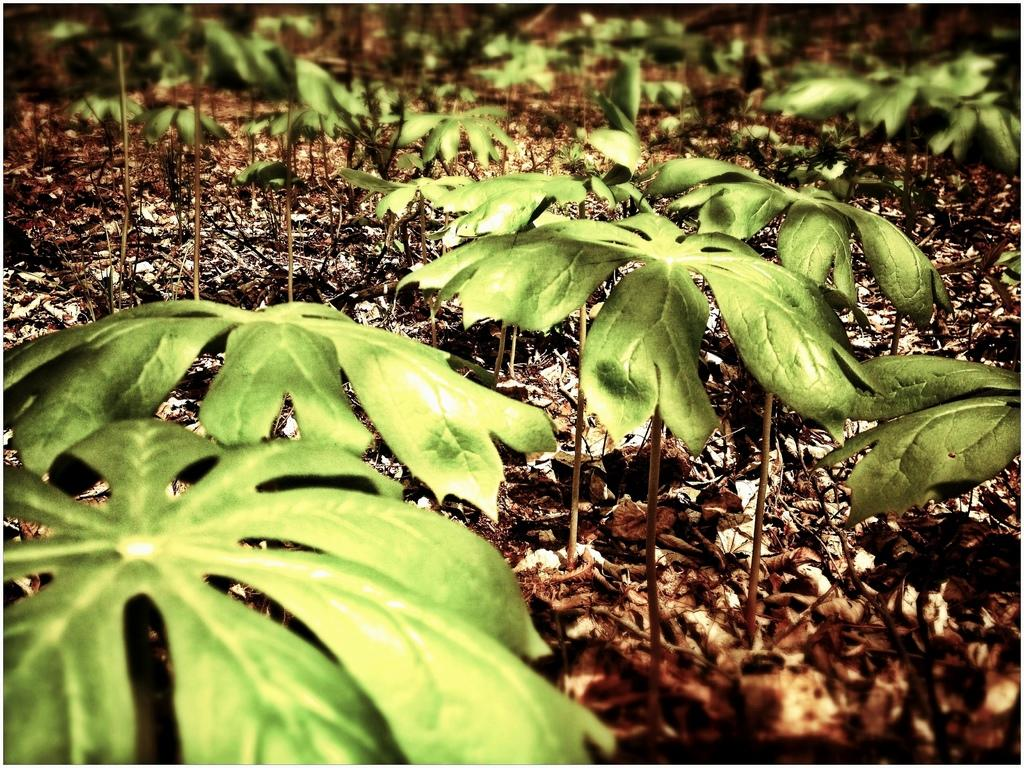What type of living organisms can be seen in the image? Plants can be seen in the image. What can be found on the ground in the image? There are dry leaves on the ground in the image. What type of story is being told by the plants in the image? There is no story being told by the plants in the image; they are simply plants. What type of apples can be seen growing on the plants in the image? There are no apples present in the image; only plants and dry leaves are visible. 